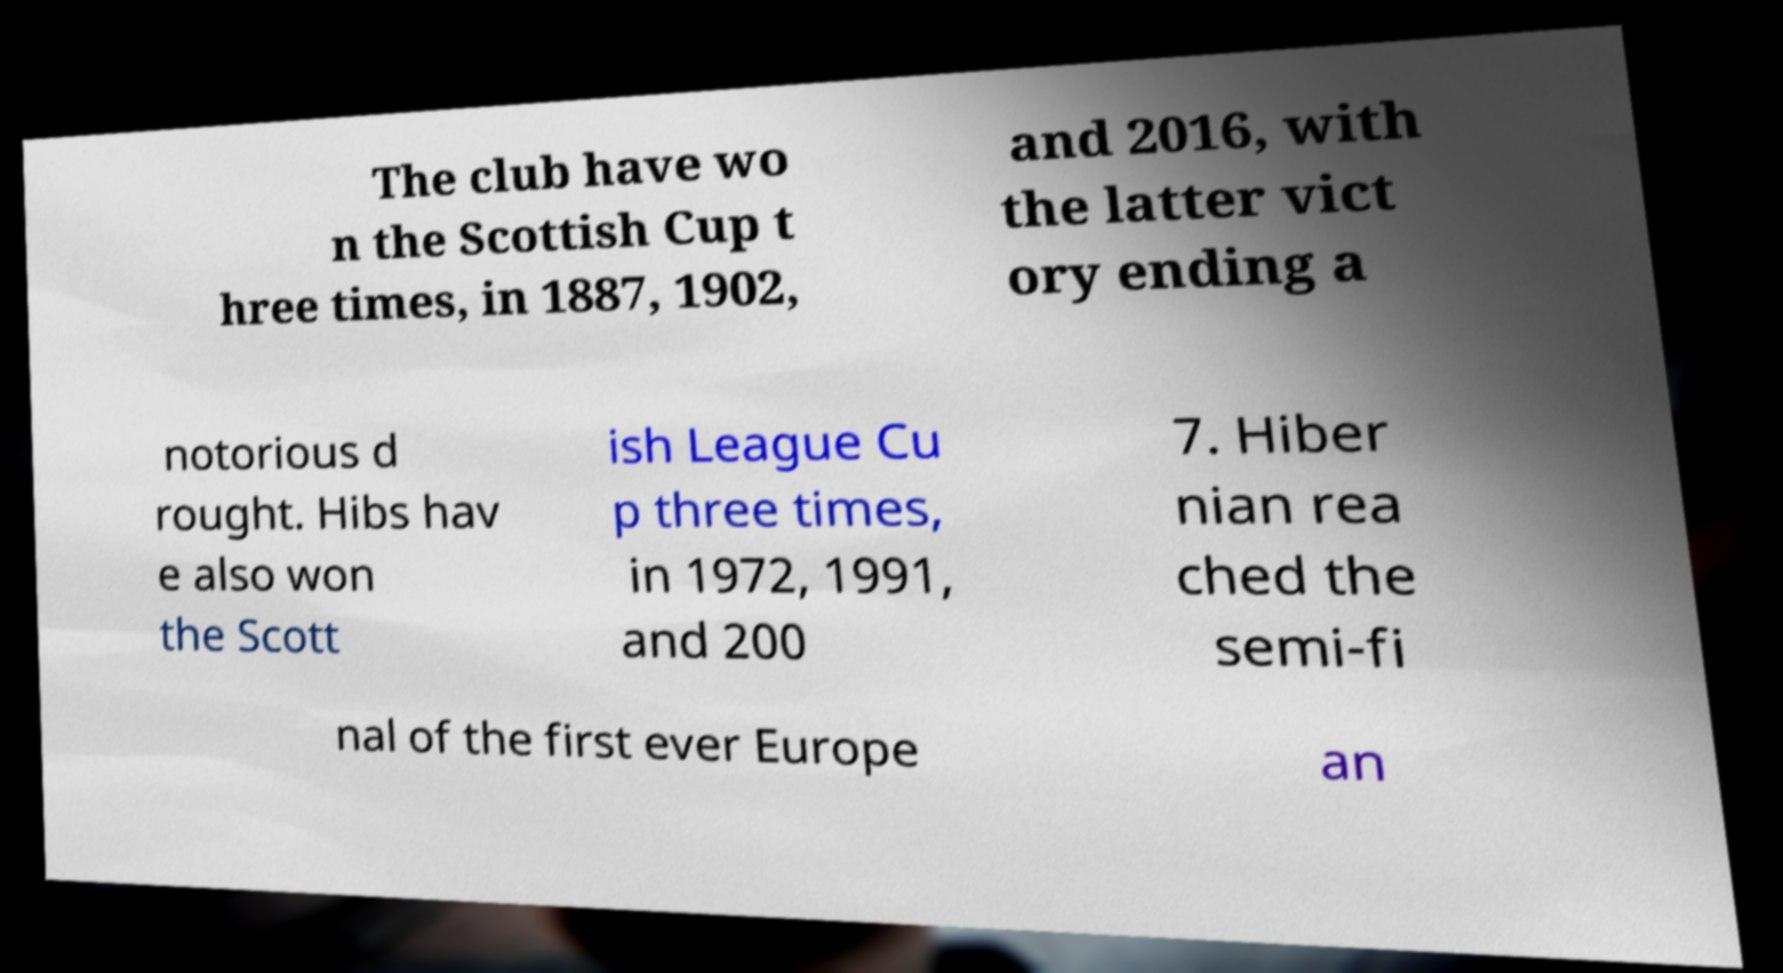Could you assist in decoding the text presented in this image and type it out clearly? The club have wo n the Scottish Cup t hree times, in 1887, 1902, and 2016, with the latter vict ory ending a notorious d rought. Hibs hav e also won the Scott ish League Cu p three times, in 1972, 1991, and 200 7. Hiber nian rea ched the semi-fi nal of the first ever Europe an 